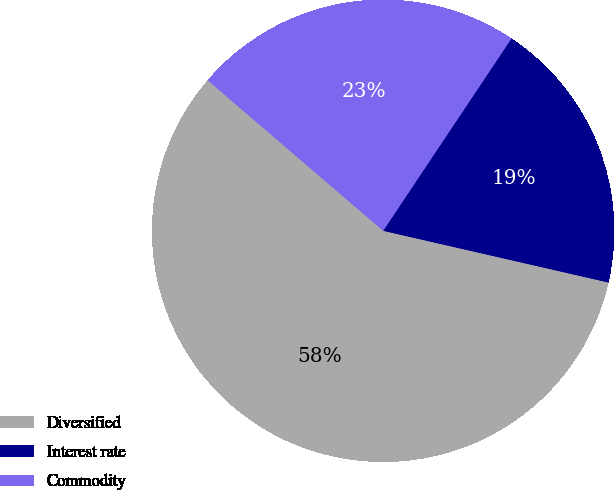<chart> <loc_0><loc_0><loc_500><loc_500><pie_chart><fcel>Diversified<fcel>Interest rate<fcel>Commodity<nl><fcel>57.69%<fcel>19.23%<fcel>23.08%<nl></chart> 